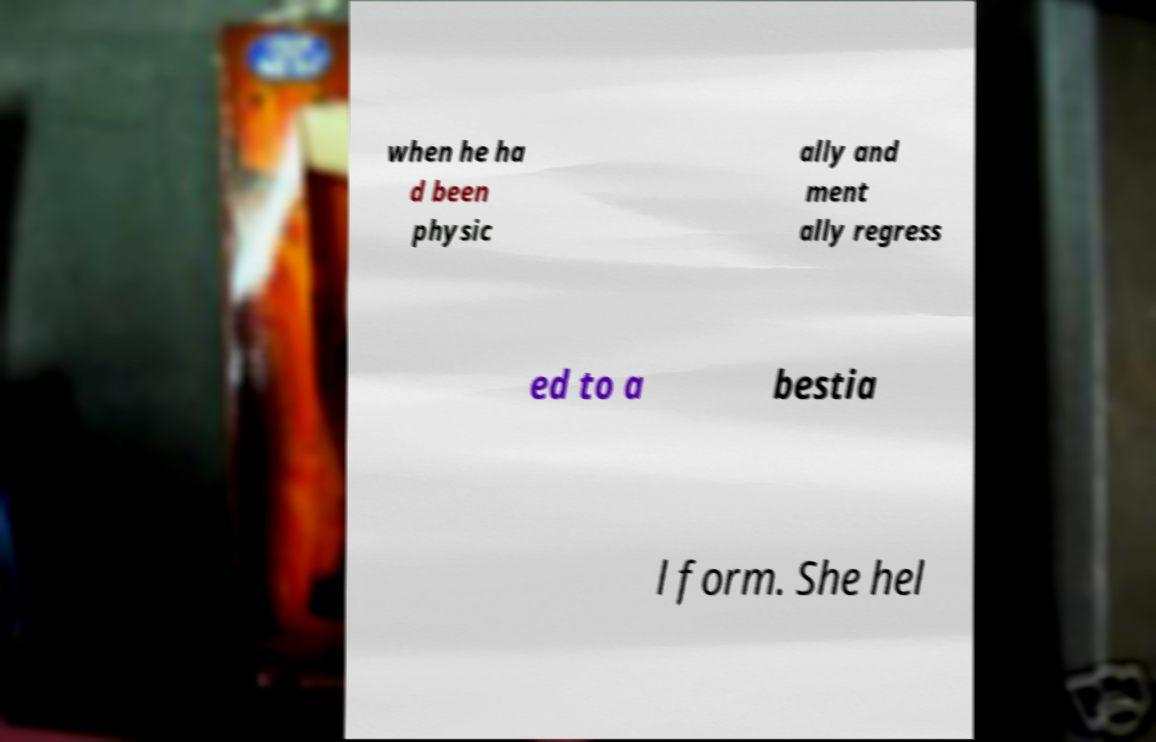Please identify and transcribe the text found in this image. when he ha d been physic ally and ment ally regress ed to a bestia l form. She hel 